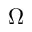<formula> <loc_0><loc_0><loc_500><loc_500>\Omega</formula> 